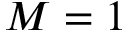Convert formula to latex. <formula><loc_0><loc_0><loc_500><loc_500>M = 1</formula> 